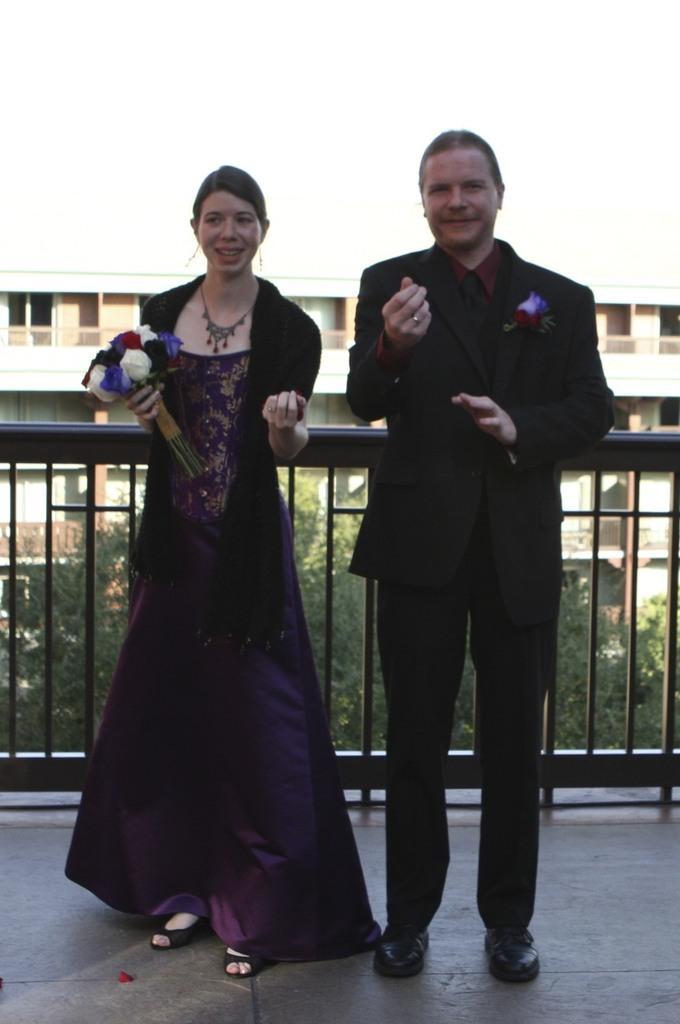Describe this image in one or two sentences. In this picture we can see a man and a woman standing, this woman is holding flowers, in the background there is a building, we can see trees here. 